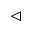Convert formula to latex. <formula><loc_0><loc_0><loc_500><loc_500>\vartriangleleft</formula> 